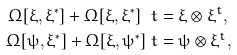Convert formula to latex. <formula><loc_0><loc_0><loc_500><loc_500>\Omega [ \xi , \xi ^ { * } ] + \Omega [ \xi , \xi ^ { * } ] ^ { \ } t & = \xi \otimes \xi ^ { t } , \\ \Omega [ \psi , \xi ^ { * } ] + \Omega [ \xi , \psi ^ { * } ] ^ { \ } t & = \psi \otimes \xi ^ { t } ,</formula> 